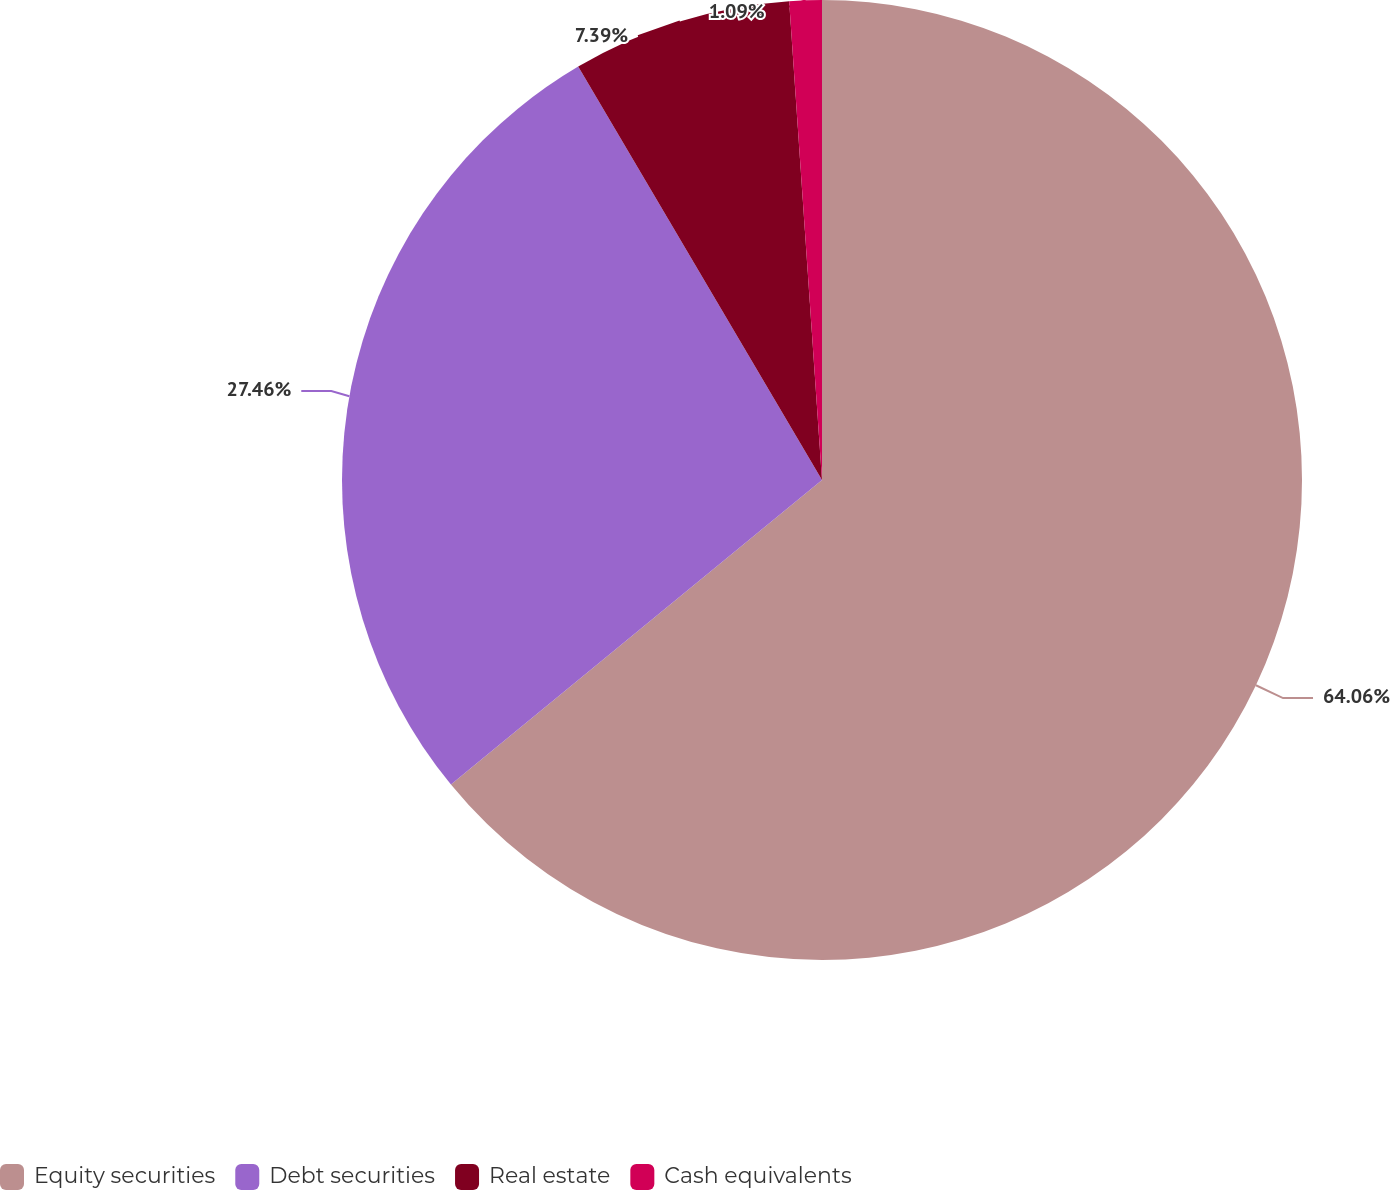<chart> <loc_0><loc_0><loc_500><loc_500><pie_chart><fcel>Equity securities<fcel>Debt securities<fcel>Real estate<fcel>Cash equivalents<nl><fcel>64.07%<fcel>27.46%<fcel>7.39%<fcel>1.09%<nl></chart> 